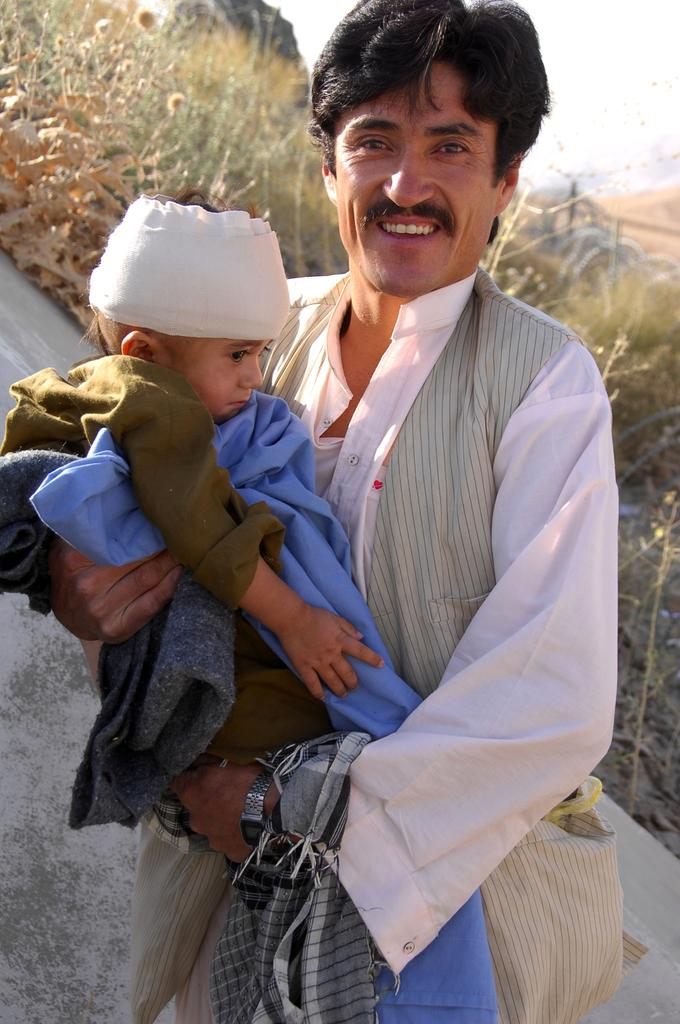What is the person in the image doing with the boy? The person is holding the boy in the image. What type of natural elements can be seen in the image? There are plants, flowers, and rocks in the image. What type of work is the person doing with the ticket in the image? There is no ticket present in the image, so it is not possible to answer that question. 